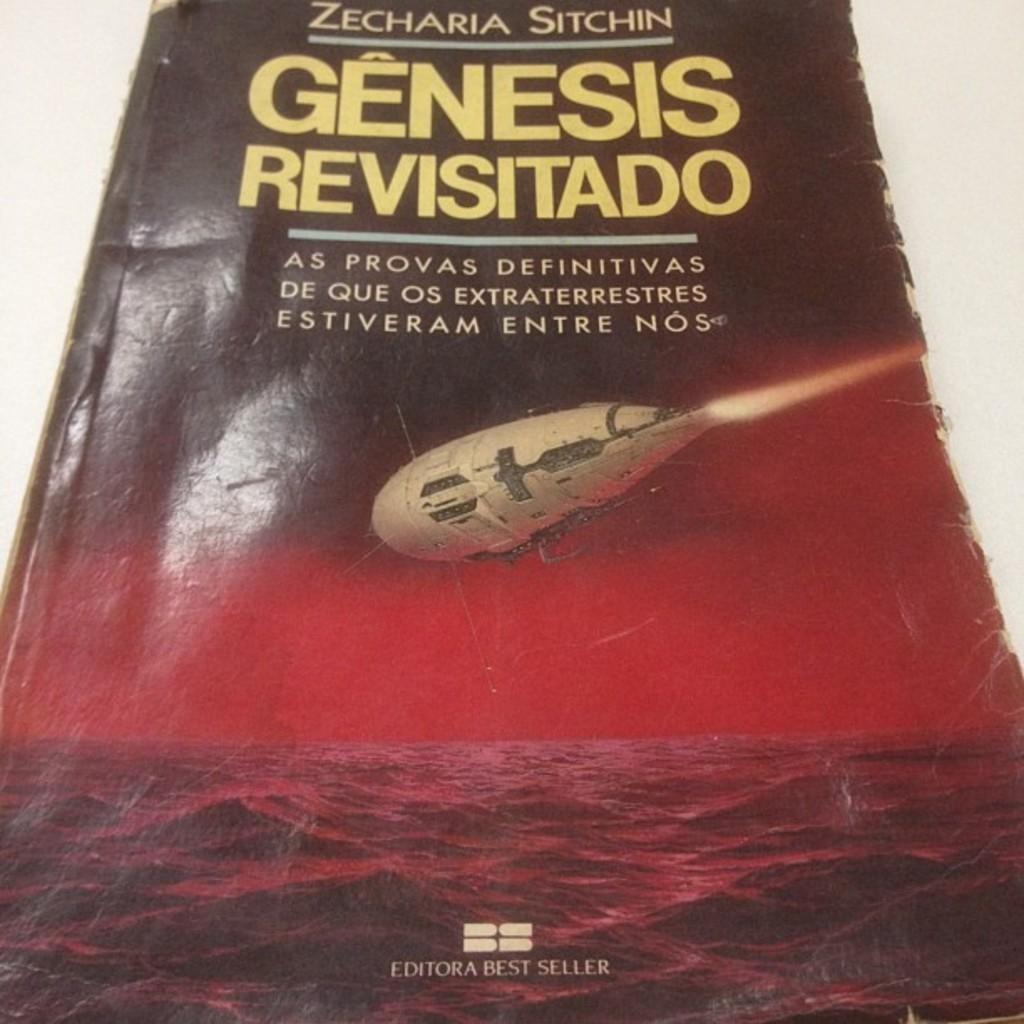<image>
Share a concise interpretation of the image provided. The cover of the book titled Genesis Revisitado by Zecharia Sitchin. 